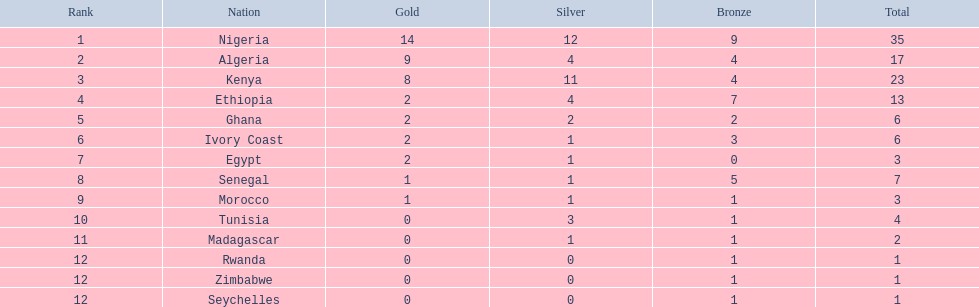What is the total number of countries that have achieved any medal winnings? 14. 